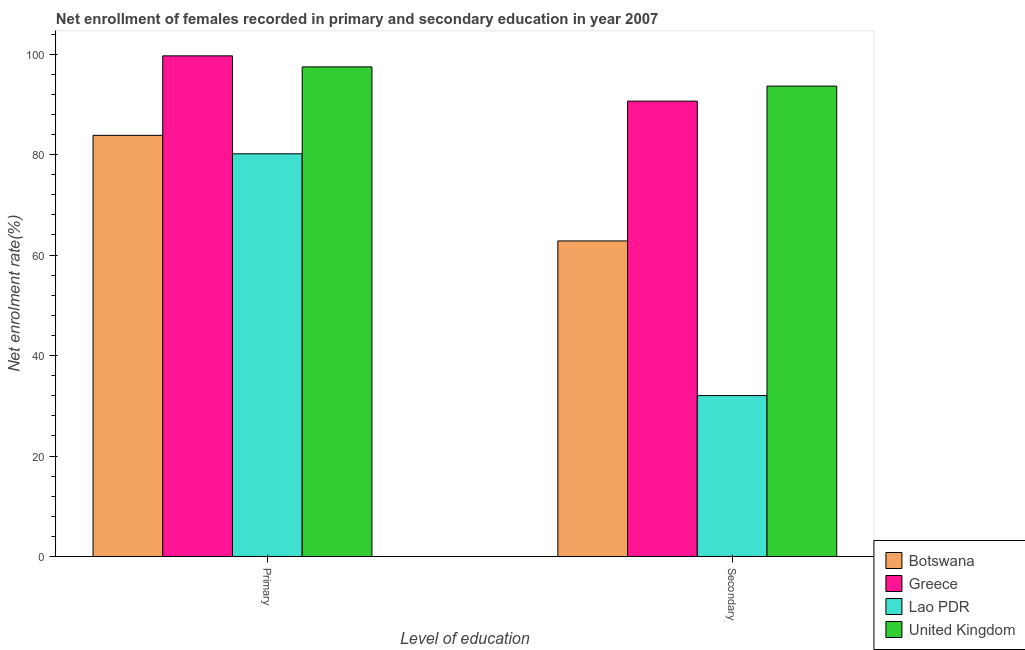How many groups of bars are there?
Keep it short and to the point. 2. How many bars are there on the 2nd tick from the right?
Give a very brief answer. 4. What is the label of the 1st group of bars from the left?
Offer a very short reply. Primary. What is the enrollment rate in secondary education in United Kingdom?
Ensure brevity in your answer.  93.64. Across all countries, what is the maximum enrollment rate in primary education?
Your response must be concise. 99.65. Across all countries, what is the minimum enrollment rate in secondary education?
Keep it short and to the point. 32.04. In which country was the enrollment rate in secondary education minimum?
Your response must be concise. Lao PDR. What is the total enrollment rate in primary education in the graph?
Make the answer very short. 361.09. What is the difference between the enrollment rate in primary education in Greece and that in Lao PDR?
Offer a very short reply. 19.5. What is the difference between the enrollment rate in primary education in Botswana and the enrollment rate in secondary education in Lao PDR?
Offer a terse response. 51.79. What is the average enrollment rate in primary education per country?
Make the answer very short. 90.27. What is the difference between the enrollment rate in secondary education and enrollment rate in primary education in Lao PDR?
Provide a short and direct response. -48.12. What is the ratio of the enrollment rate in secondary education in Lao PDR to that in United Kingdom?
Offer a very short reply. 0.34. Is the enrollment rate in secondary education in Lao PDR less than that in Botswana?
Provide a short and direct response. Yes. In how many countries, is the enrollment rate in primary education greater than the average enrollment rate in primary education taken over all countries?
Offer a terse response. 2. What does the 3rd bar from the left in Secondary represents?
Your answer should be very brief. Lao PDR. What does the 2nd bar from the right in Secondary represents?
Offer a terse response. Lao PDR. How many bars are there?
Your answer should be compact. 8. Are all the bars in the graph horizontal?
Ensure brevity in your answer.  No. Does the graph contain any zero values?
Your response must be concise. No. Does the graph contain grids?
Offer a very short reply. No. Where does the legend appear in the graph?
Ensure brevity in your answer.  Bottom right. How many legend labels are there?
Provide a succinct answer. 4. How are the legend labels stacked?
Offer a very short reply. Vertical. What is the title of the graph?
Offer a very short reply. Net enrollment of females recorded in primary and secondary education in year 2007. Does "Afghanistan" appear as one of the legend labels in the graph?
Provide a succinct answer. No. What is the label or title of the X-axis?
Your response must be concise. Level of education. What is the label or title of the Y-axis?
Your response must be concise. Net enrolment rate(%). What is the Net enrolment rate(%) of Botswana in Primary?
Keep it short and to the point. 83.83. What is the Net enrolment rate(%) in Greece in Primary?
Ensure brevity in your answer.  99.65. What is the Net enrolment rate(%) in Lao PDR in Primary?
Offer a very short reply. 80.16. What is the Net enrolment rate(%) in United Kingdom in Primary?
Ensure brevity in your answer.  97.46. What is the Net enrolment rate(%) of Botswana in Secondary?
Offer a very short reply. 62.81. What is the Net enrolment rate(%) in Greece in Secondary?
Offer a terse response. 90.64. What is the Net enrolment rate(%) in Lao PDR in Secondary?
Your answer should be very brief. 32.04. What is the Net enrolment rate(%) of United Kingdom in Secondary?
Keep it short and to the point. 93.64. Across all Level of education, what is the maximum Net enrolment rate(%) of Botswana?
Provide a succinct answer. 83.83. Across all Level of education, what is the maximum Net enrolment rate(%) in Greece?
Your answer should be compact. 99.65. Across all Level of education, what is the maximum Net enrolment rate(%) of Lao PDR?
Make the answer very short. 80.16. Across all Level of education, what is the maximum Net enrolment rate(%) in United Kingdom?
Give a very brief answer. 97.46. Across all Level of education, what is the minimum Net enrolment rate(%) of Botswana?
Provide a short and direct response. 62.81. Across all Level of education, what is the minimum Net enrolment rate(%) in Greece?
Your answer should be very brief. 90.64. Across all Level of education, what is the minimum Net enrolment rate(%) in Lao PDR?
Provide a short and direct response. 32.04. Across all Level of education, what is the minimum Net enrolment rate(%) of United Kingdom?
Ensure brevity in your answer.  93.64. What is the total Net enrolment rate(%) of Botswana in the graph?
Offer a terse response. 146.64. What is the total Net enrolment rate(%) in Greece in the graph?
Provide a short and direct response. 190.29. What is the total Net enrolment rate(%) of Lao PDR in the graph?
Make the answer very short. 112.19. What is the total Net enrolment rate(%) of United Kingdom in the graph?
Provide a succinct answer. 191.09. What is the difference between the Net enrolment rate(%) in Botswana in Primary and that in Secondary?
Offer a terse response. 21.01. What is the difference between the Net enrolment rate(%) in Greece in Primary and that in Secondary?
Provide a succinct answer. 9.01. What is the difference between the Net enrolment rate(%) of Lao PDR in Primary and that in Secondary?
Offer a terse response. 48.12. What is the difference between the Net enrolment rate(%) of United Kingdom in Primary and that in Secondary?
Provide a short and direct response. 3.82. What is the difference between the Net enrolment rate(%) in Botswana in Primary and the Net enrolment rate(%) in Greece in Secondary?
Make the answer very short. -6.81. What is the difference between the Net enrolment rate(%) of Botswana in Primary and the Net enrolment rate(%) of Lao PDR in Secondary?
Provide a short and direct response. 51.79. What is the difference between the Net enrolment rate(%) in Botswana in Primary and the Net enrolment rate(%) in United Kingdom in Secondary?
Your answer should be very brief. -9.81. What is the difference between the Net enrolment rate(%) of Greece in Primary and the Net enrolment rate(%) of Lao PDR in Secondary?
Your answer should be compact. 67.62. What is the difference between the Net enrolment rate(%) in Greece in Primary and the Net enrolment rate(%) in United Kingdom in Secondary?
Provide a short and direct response. 6.01. What is the difference between the Net enrolment rate(%) in Lao PDR in Primary and the Net enrolment rate(%) in United Kingdom in Secondary?
Offer a terse response. -13.48. What is the average Net enrolment rate(%) in Botswana per Level of education?
Provide a short and direct response. 73.32. What is the average Net enrolment rate(%) in Greece per Level of education?
Keep it short and to the point. 95.15. What is the average Net enrolment rate(%) in Lao PDR per Level of education?
Your answer should be very brief. 56.1. What is the average Net enrolment rate(%) in United Kingdom per Level of education?
Your answer should be very brief. 95.55. What is the difference between the Net enrolment rate(%) in Botswana and Net enrolment rate(%) in Greece in Primary?
Give a very brief answer. -15.82. What is the difference between the Net enrolment rate(%) in Botswana and Net enrolment rate(%) in Lao PDR in Primary?
Give a very brief answer. 3.67. What is the difference between the Net enrolment rate(%) in Botswana and Net enrolment rate(%) in United Kingdom in Primary?
Provide a short and direct response. -13.63. What is the difference between the Net enrolment rate(%) in Greece and Net enrolment rate(%) in Lao PDR in Primary?
Offer a terse response. 19.5. What is the difference between the Net enrolment rate(%) of Greece and Net enrolment rate(%) of United Kingdom in Primary?
Give a very brief answer. 2.2. What is the difference between the Net enrolment rate(%) in Lao PDR and Net enrolment rate(%) in United Kingdom in Primary?
Provide a succinct answer. -17.3. What is the difference between the Net enrolment rate(%) in Botswana and Net enrolment rate(%) in Greece in Secondary?
Ensure brevity in your answer.  -27.83. What is the difference between the Net enrolment rate(%) of Botswana and Net enrolment rate(%) of Lao PDR in Secondary?
Provide a short and direct response. 30.78. What is the difference between the Net enrolment rate(%) in Botswana and Net enrolment rate(%) in United Kingdom in Secondary?
Keep it short and to the point. -30.82. What is the difference between the Net enrolment rate(%) in Greece and Net enrolment rate(%) in Lao PDR in Secondary?
Give a very brief answer. 58.61. What is the difference between the Net enrolment rate(%) in Greece and Net enrolment rate(%) in United Kingdom in Secondary?
Provide a short and direct response. -3. What is the difference between the Net enrolment rate(%) of Lao PDR and Net enrolment rate(%) of United Kingdom in Secondary?
Make the answer very short. -61.6. What is the ratio of the Net enrolment rate(%) in Botswana in Primary to that in Secondary?
Ensure brevity in your answer.  1.33. What is the ratio of the Net enrolment rate(%) in Greece in Primary to that in Secondary?
Keep it short and to the point. 1.1. What is the ratio of the Net enrolment rate(%) of Lao PDR in Primary to that in Secondary?
Your response must be concise. 2.5. What is the ratio of the Net enrolment rate(%) of United Kingdom in Primary to that in Secondary?
Offer a terse response. 1.04. What is the difference between the highest and the second highest Net enrolment rate(%) of Botswana?
Make the answer very short. 21.01. What is the difference between the highest and the second highest Net enrolment rate(%) of Greece?
Ensure brevity in your answer.  9.01. What is the difference between the highest and the second highest Net enrolment rate(%) of Lao PDR?
Provide a succinct answer. 48.12. What is the difference between the highest and the second highest Net enrolment rate(%) of United Kingdom?
Provide a short and direct response. 3.82. What is the difference between the highest and the lowest Net enrolment rate(%) of Botswana?
Offer a terse response. 21.01. What is the difference between the highest and the lowest Net enrolment rate(%) in Greece?
Provide a short and direct response. 9.01. What is the difference between the highest and the lowest Net enrolment rate(%) of Lao PDR?
Provide a succinct answer. 48.12. What is the difference between the highest and the lowest Net enrolment rate(%) in United Kingdom?
Ensure brevity in your answer.  3.82. 